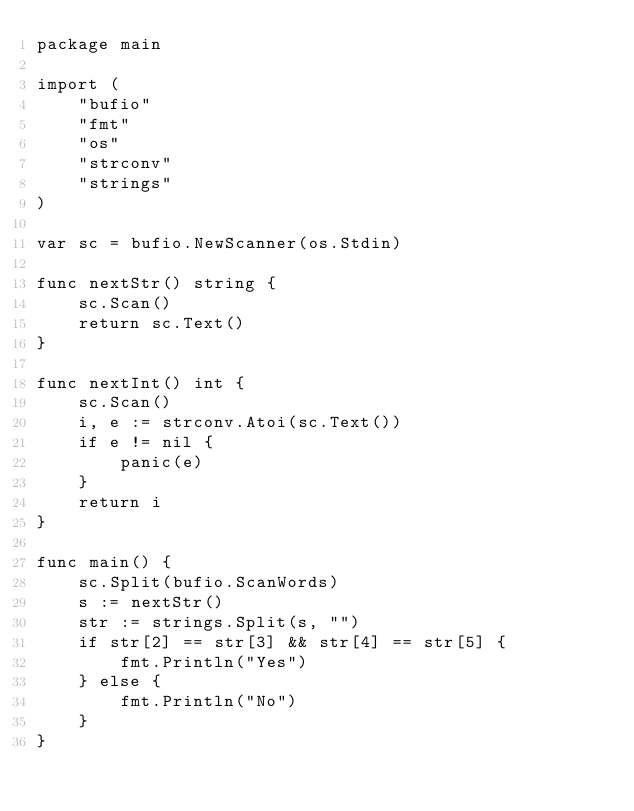<code> <loc_0><loc_0><loc_500><loc_500><_Go_>package main

import (
	"bufio"
	"fmt"
	"os"
	"strconv"
	"strings"
)

var sc = bufio.NewScanner(os.Stdin)

func nextStr() string {
	sc.Scan()
	return sc.Text()
}

func nextInt() int {
	sc.Scan()
	i, e := strconv.Atoi(sc.Text())
	if e != nil {
		panic(e)
	}
	return i
}

func main() {
	sc.Split(bufio.ScanWords)
	s := nextStr()
	str := strings.Split(s, "")
	if str[2] == str[3] && str[4] == str[5] {
		fmt.Println("Yes")
	} else {
		fmt.Println("No")
	}
}
</code> 